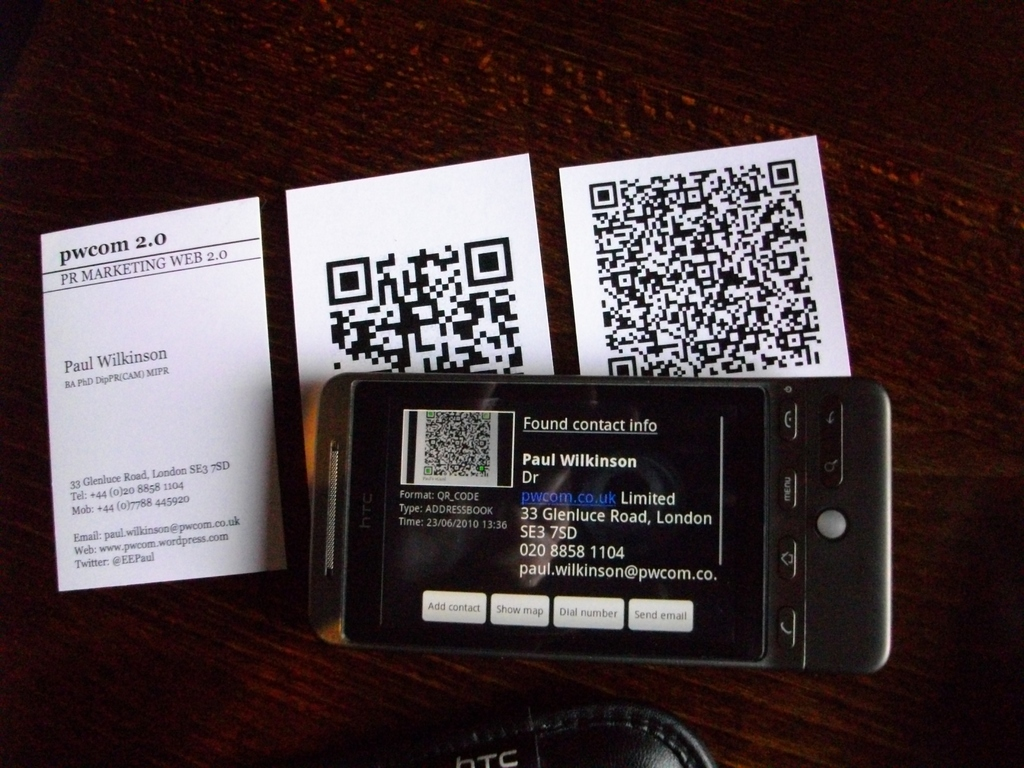Provide a one-sentence caption for the provided image. The image displays a mobile phone lying on a table, showing a contact information screen for Paul Wilkinson, alongside two business cards and QR codes, highlighting modern digital marketing tools. 